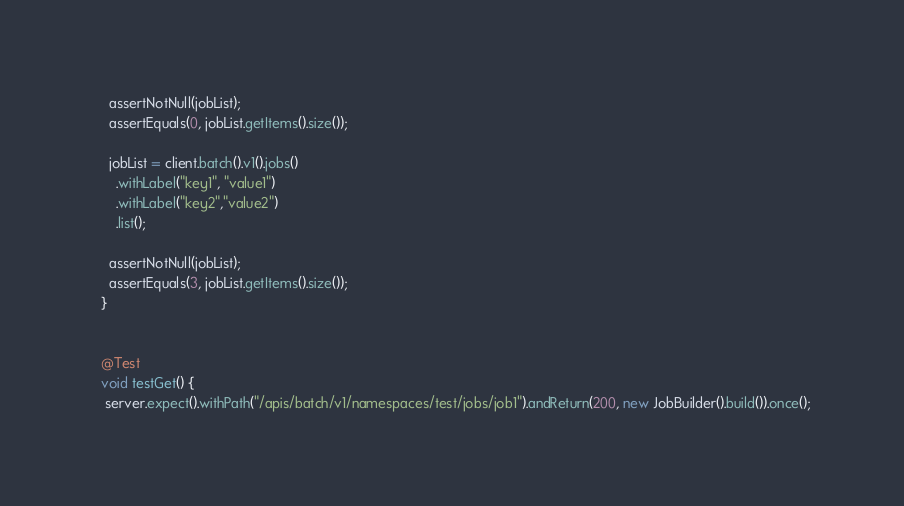Convert code to text. <code><loc_0><loc_0><loc_500><loc_500><_Java_>
    assertNotNull(jobList);
    assertEquals(0, jobList.getItems().size());

    jobList = client.batch().v1().jobs()
      .withLabel("key1", "value1")
      .withLabel("key2","value2")
      .list();

    assertNotNull(jobList);
    assertEquals(3, jobList.getItems().size());
  }


  @Test
  void testGet() {
   server.expect().withPath("/apis/batch/v1/namespaces/test/jobs/job1").andReturn(200, new JobBuilder().build()).once();</code> 